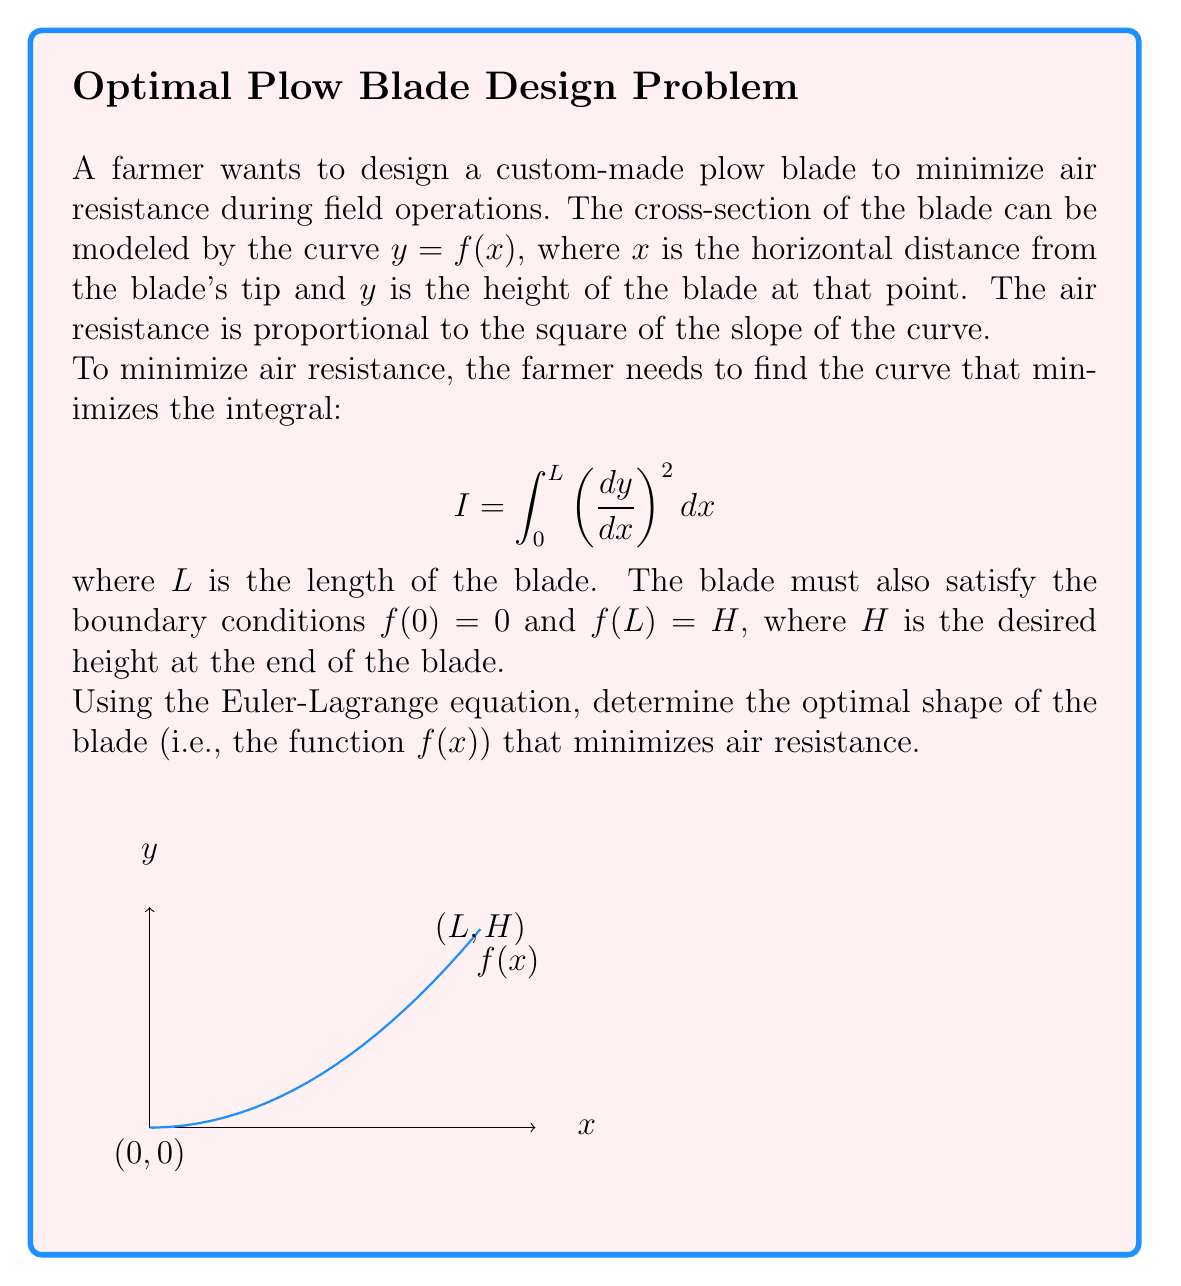Can you solve this math problem? To solve this problem, we'll use the Euler-Lagrange equation from variational calculus:

1) The Euler-Lagrange equation is:
   $$ \frac{\partial F}{\partial y} - \frac{d}{dx}\left(\frac{\partial F}{\partial y'}\right) = 0 $$
   where $F = (y')^2$ in our case, and $y' = \frac{dy}{dx}$.

2) Calculate the partial derivatives:
   $\frac{\partial F}{\partial y} = 0$
   $\frac{\partial F}{\partial y'} = 2y'$

3) Substitute into the Euler-Lagrange equation:
   $$ 0 - \frac{d}{dx}(2y') = 0 $$

4) Simplify:
   $$ \frac{d}{dx}(y') = 0 $$

5) Integrate both sides:
   $$ y' = C_1 $$
   where $C_1$ is a constant of integration.

6) Integrate again:
   $$ y = C_1x + C_2 $$
   where $C_2$ is another constant of integration.

7) Apply the boundary conditions:
   At $x = 0$: $f(0) = 0$, so $C_2 = 0$
   At $x = L$: $f(L) = H$, so $H = C_1L$

8) Solve for $C_1$:
   $$ C_1 = \frac{H}{L} $$

9) The optimal shape of the blade is therefore:
   $$ f(x) = \frac{H}{L}x $$

This represents a straight line from $(0,0)$ to $(L,H)$.
Answer: $f(x) = \frac{H}{L}x$ 